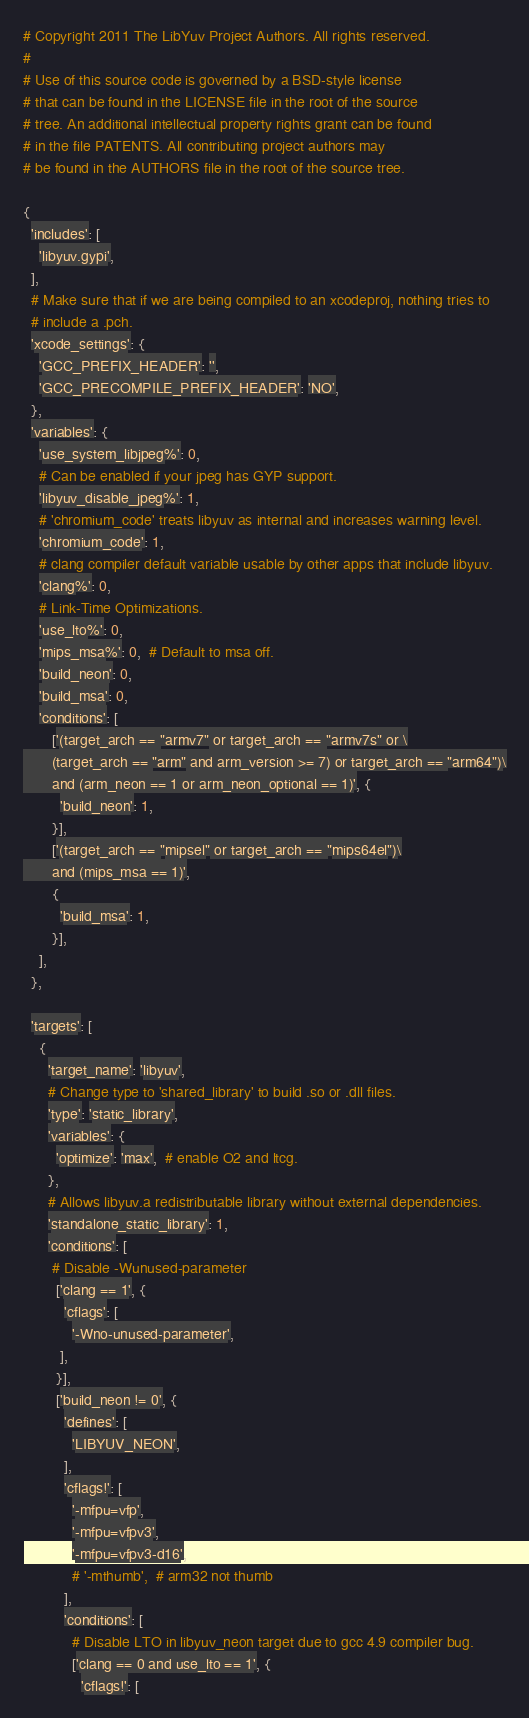<code> <loc_0><loc_0><loc_500><loc_500><_Python_># Copyright 2011 The LibYuv Project Authors. All rights reserved.
#
# Use of this source code is governed by a BSD-style license
# that can be found in the LICENSE file in the root of the source
# tree. An additional intellectual property rights grant can be found
# in the file PATENTS. All contributing project authors may
# be found in the AUTHORS file in the root of the source tree.

{
  'includes': [
    'libyuv.gypi',
  ],
  # Make sure that if we are being compiled to an xcodeproj, nothing tries to
  # include a .pch.
  'xcode_settings': {
    'GCC_PREFIX_HEADER': '',
    'GCC_PRECOMPILE_PREFIX_HEADER': 'NO',
  },
  'variables': {
    'use_system_libjpeg%': 0,
    # Can be enabled if your jpeg has GYP support.
    'libyuv_disable_jpeg%': 1,
    # 'chromium_code' treats libyuv as internal and increases warning level.
    'chromium_code': 1,
    # clang compiler default variable usable by other apps that include libyuv.
    'clang%': 0,
    # Link-Time Optimizations.
    'use_lto%': 0,
    'mips_msa%': 0,  # Default to msa off.
    'build_neon': 0,
    'build_msa': 0,
    'conditions': [
       ['(target_arch == "armv7" or target_arch == "armv7s" or \
       (target_arch == "arm" and arm_version >= 7) or target_arch == "arm64")\
       and (arm_neon == 1 or arm_neon_optional == 1)', {
         'build_neon': 1,
       }],
       ['(target_arch == "mipsel" or target_arch == "mips64el")\
       and (mips_msa == 1)',
       {
         'build_msa': 1,
       }],
    ],
  },

  'targets': [
    {
      'target_name': 'libyuv',
      # Change type to 'shared_library' to build .so or .dll files.
      'type': 'static_library',
      'variables': {
        'optimize': 'max',  # enable O2 and ltcg.
      },
      # Allows libyuv.a redistributable library without external dependencies.
      'standalone_static_library': 1,
      'conditions': [
       # Disable -Wunused-parameter
        ['clang == 1', {
          'cflags': [
            '-Wno-unused-parameter',
         ],
        }],
        ['build_neon != 0', {
          'defines': [
            'LIBYUV_NEON',
          ],
          'cflags!': [
            '-mfpu=vfp',
            '-mfpu=vfpv3',
            '-mfpu=vfpv3-d16',
            # '-mthumb',  # arm32 not thumb
          ],
          'conditions': [
            # Disable LTO in libyuv_neon target due to gcc 4.9 compiler bug.
            ['clang == 0 and use_lto == 1', {
              'cflags!': [</code> 